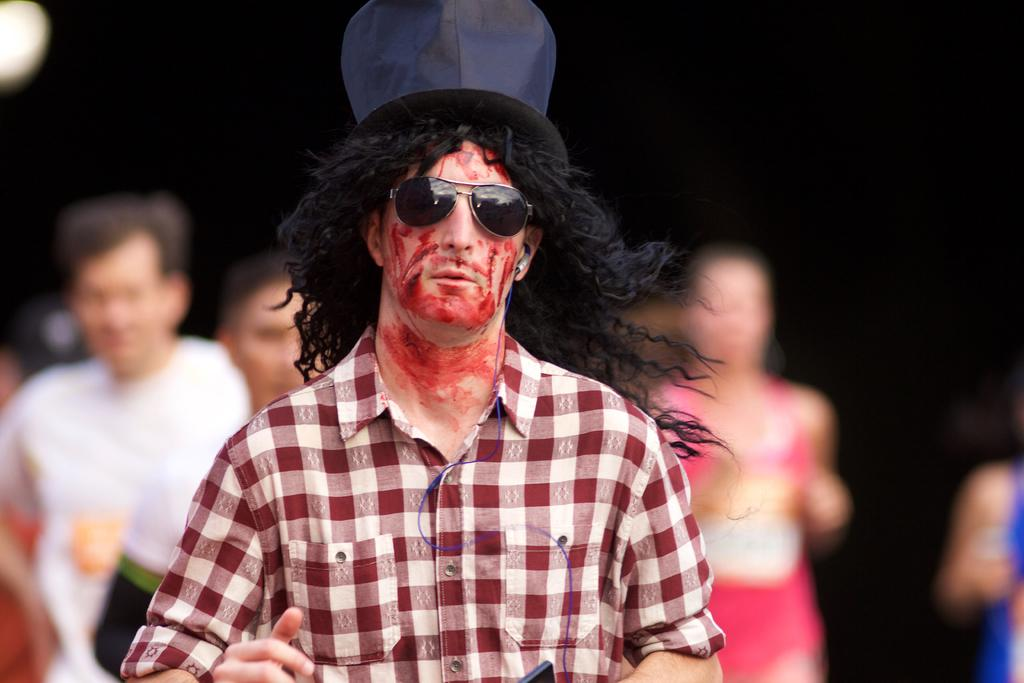Who is present in the image? There is a man in the image. What is the man wearing on his face? The man is wearing goggles. What type of headwear is the man wearing? The man is wearing a hat. What can be observed about the people in the background of the image? The people in the background are blurred. How would you describe the lighting in the image? The background of the image is dark. What type of key is the man holding in the image? There is no key present in the image; the man is wearing goggles and a hat. What color is the chalk used by the man in the image? There is no chalk present in the image; the man is wearing goggles and a hat. 